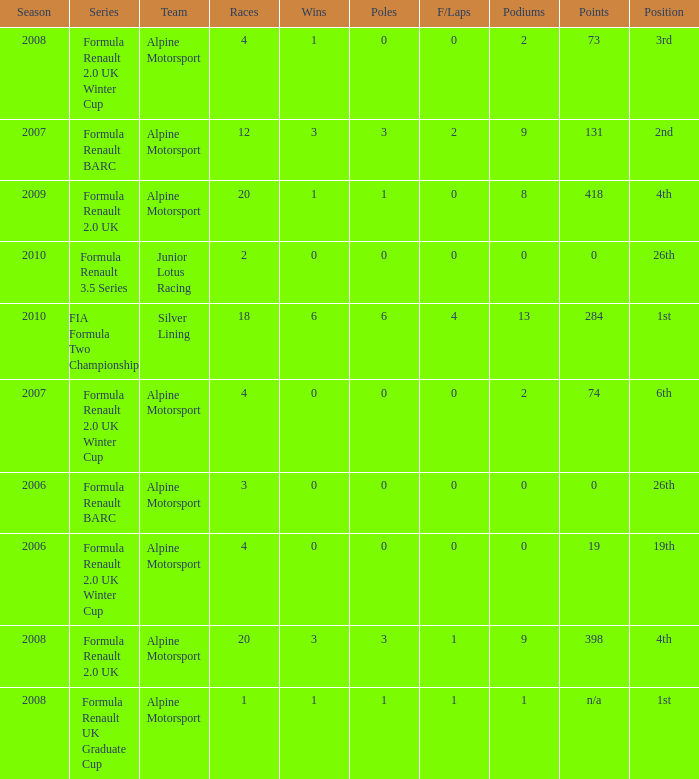What was the earliest season where podium was 9? 2007.0. 